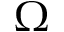<formula> <loc_0><loc_0><loc_500><loc_500>\Omega</formula> 